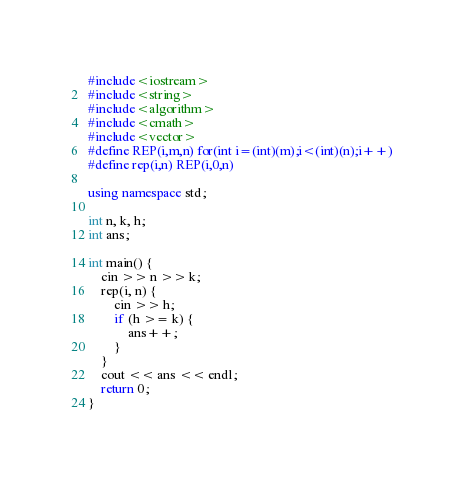<code> <loc_0><loc_0><loc_500><loc_500><_C++_>#include<iostream>
#include<string>
#include<algorithm>
#include<cmath>
#include<vector>
#define REP(i,m,n) for(int i=(int)(m);i<(int)(n);i++)
#define rep(i,n) REP(i,0,n)

using namespace std;

int n, k, h;
int ans;

int main() {
	cin >> n >> k;
	rep(i, n) {
		cin >> h;
		if (h >= k) {
			ans++;
		}
	}
	cout << ans << endl;
	return 0;
}</code> 